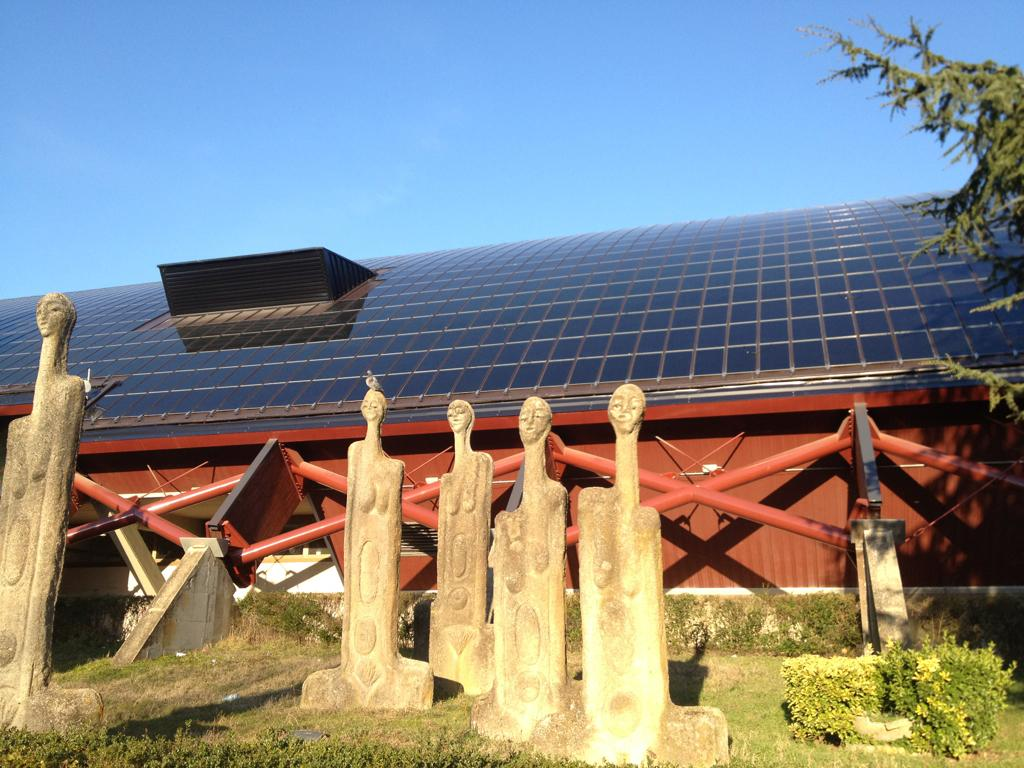What can be seen in the image besides the plants and tree? There are statues in the image. What is located to the right of the image? There are plants and a tree to the right of the image. What can be seen in the background of the image? There are buildings and a blue sky in the background of the image. What type of breakfast is the farmer eating in the image? There is no farmer or breakfast present in the image; it features statues, plants, a tree, buildings, and a blue sky. Can you see any ghosts in the image? There are no ghosts present in the image. 